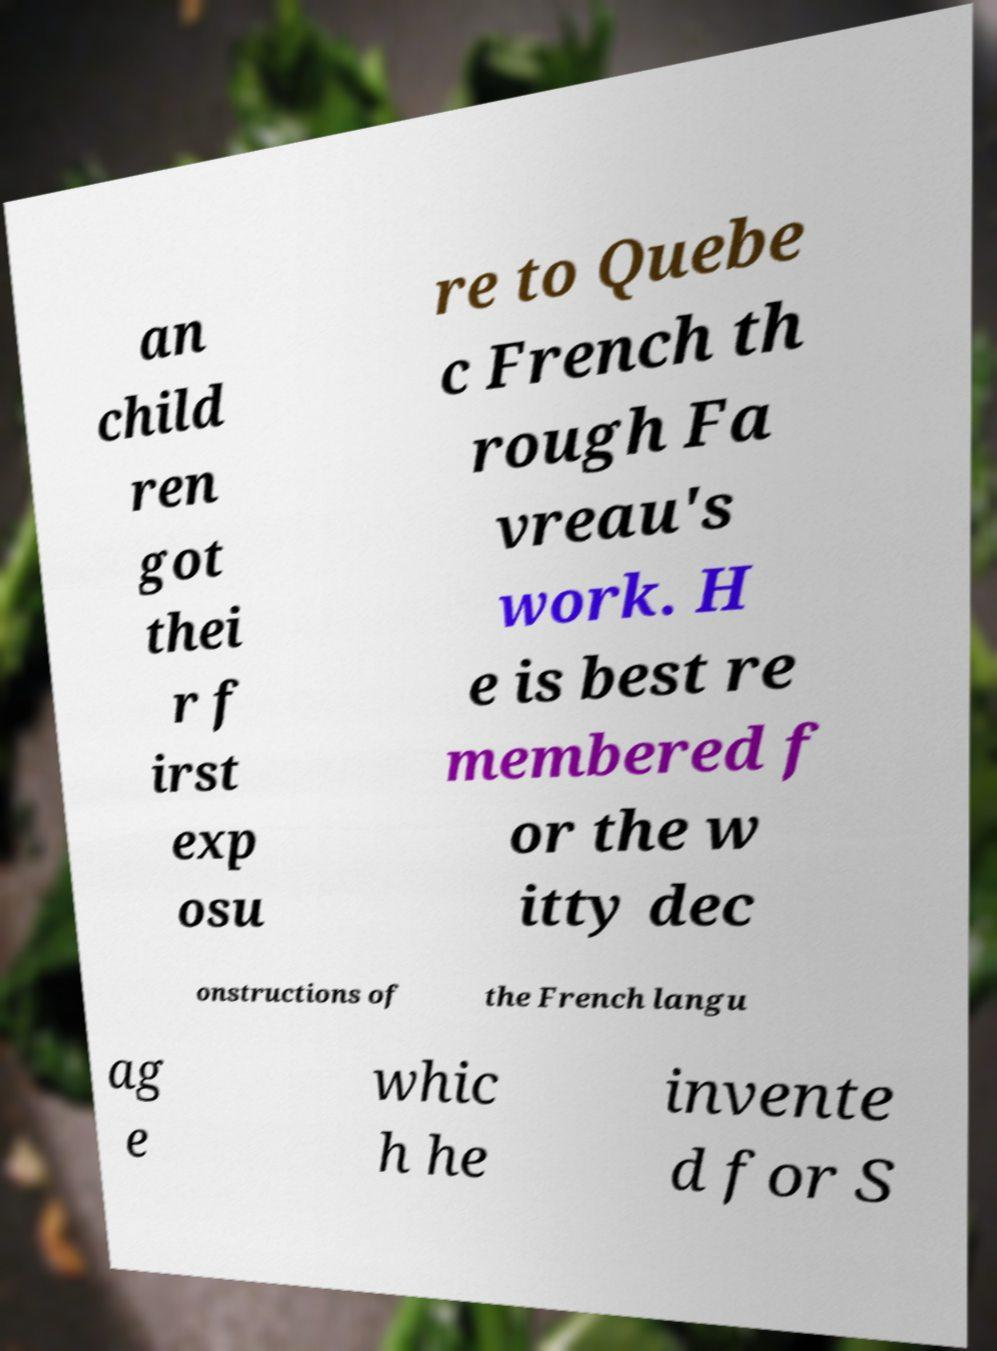Can you accurately transcribe the text from the provided image for me? an child ren got thei r f irst exp osu re to Quebe c French th rough Fa vreau's work. H e is best re membered f or the w itty dec onstructions of the French langu ag e whic h he invente d for S 